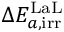<formula> <loc_0><loc_0><loc_500><loc_500>\Delta E _ { a , i r r } ^ { L a L }</formula> 